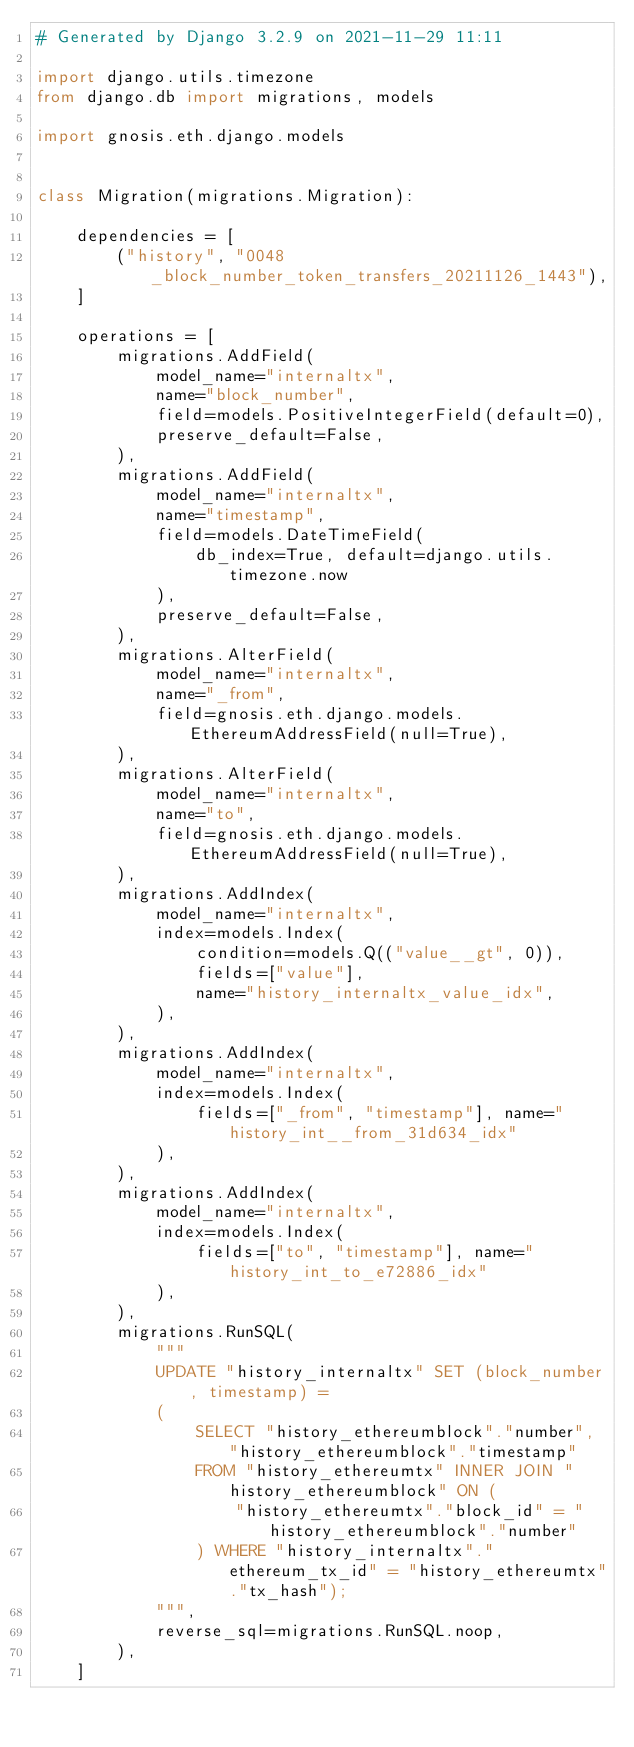<code> <loc_0><loc_0><loc_500><loc_500><_Python_># Generated by Django 3.2.9 on 2021-11-29 11:11

import django.utils.timezone
from django.db import migrations, models

import gnosis.eth.django.models


class Migration(migrations.Migration):

    dependencies = [
        ("history", "0048_block_number_token_transfers_20211126_1443"),
    ]

    operations = [
        migrations.AddField(
            model_name="internaltx",
            name="block_number",
            field=models.PositiveIntegerField(default=0),
            preserve_default=False,
        ),
        migrations.AddField(
            model_name="internaltx",
            name="timestamp",
            field=models.DateTimeField(
                db_index=True, default=django.utils.timezone.now
            ),
            preserve_default=False,
        ),
        migrations.AlterField(
            model_name="internaltx",
            name="_from",
            field=gnosis.eth.django.models.EthereumAddressField(null=True),
        ),
        migrations.AlterField(
            model_name="internaltx",
            name="to",
            field=gnosis.eth.django.models.EthereumAddressField(null=True),
        ),
        migrations.AddIndex(
            model_name="internaltx",
            index=models.Index(
                condition=models.Q(("value__gt", 0)),
                fields=["value"],
                name="history_internaltx_value_idx",
            ),
        ),
        migrations.AddIndex(
            model_name="internaltx",
            index=models.Index(
                fields=["_from", "timestamp"], name="history_int__from_31d634_idx"
            ),
        ),
        migrations.AddIndex(
            model_name="internaltx",
            index=models.Index(
                fields=["to", "timestamp"], name="history_int_to_e72886_idx"
            ),
        ),
        migrations.RunSQL(
            """
            UPDATE "history_internaltx" SET (block_number, timestamp) =
            (
                SELECT "history_ethereumblock"."number", "history_ethereumblock"."timestamp"
                FROM "history_ethereumtx" INNER JOIN "history_ethereumblock" ON (
                    "history_ethereumtx"."block_id" = "history_ethereumblock"."number"
                ) WHERE "history_internaltx"."ethereum_tx_id" = "history_ethereumtx"."tx_hash");
            """,
            reverse_sql=migrations.RunSQL.noop,
        ),
    ]
</code> 